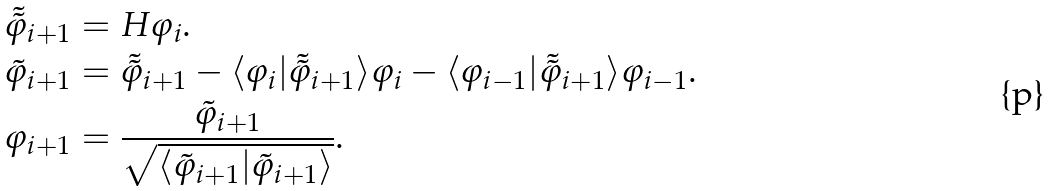<formula> <loc_0><loc_0><loc_500><loc_500>\tilde { \tilde { \varphi } } _ { i + 1 } & = H \varphi _ { i } . \\ \tilde { \varphi } _ { i + 1 } & = \tilde { \tilde { \varphi } } _ { i + 1 } - \langle \varphi _ { i } | \tilde { \tilde { \varphi } } _ { i + 1 } \rangle \varphi _ { i } - \langle \varphi _ { i - 1 } | \tilde { \tilde { \varphi } } _ { i + 1 } \rangle \varphi _ { i - 1 } . \\ \varphi _ { i + 1 } & = \frac { \tilde { \varphi } _ { i + 1 } } { \sqrt { \langle \tilde { \varphi } _ { i + 1 } | \tilde { \varphi } _ { i + 1 } \rangle } } .</formula> 